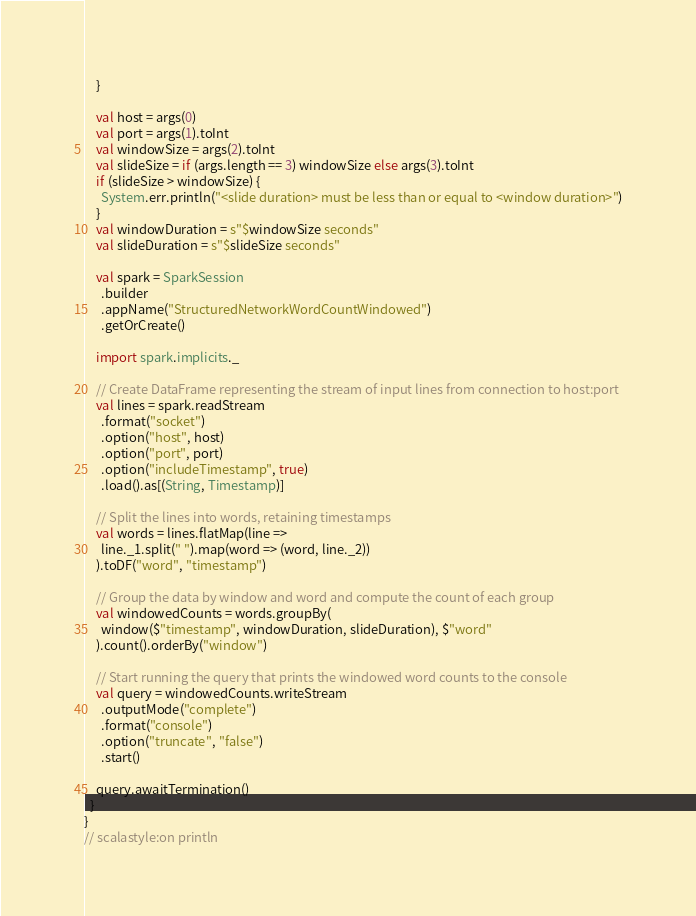Convert code to text. <code><loc_0><loc_0><loc_500><loc_500><_Scala_>    }

    val host = args(0)
    val port = args(1).toInt
    val windowSize = args(2).toInt
    val slideSize = if (args.length == 3) windowSize else args(3).toInt
    if (slideSize > windowSize) {
      System.err.println("<slide duration> must be less than or equal to <window duration>")
    }
    val windowDuration = s"$windowSize seconds"
    val slideDuration = s"$slideSize seconds"

    val spark = SparkSession
      .builder
      .appName("StructuredNetworkWordCountWindowed")
      .getOrCreate()

    import spark.implicits._

    // Create DataFrame representing the stream of input lines from connection to host:port
    val lines = spark.readStream
      .format("socket")
      .option("host", host)
      .option("port", port)
      .option("includeTimestamp", true)
      .load().as[(String, Timestamp)]

    // Split the lines into words, retaining timestamps
    val words = lines.flatMap(line =>
      line._1.split(" ").map(word => (word, line._2))
    ).toDF("word", "timestamp")

    // Group the data by window and word and compute the count of each group
    val windowedCounts = words.groupBy(
      window($"timestamp", windowDuration, slideDuration), $"word"
    ).count().orderBy("window")

    // Start running the query that prints the windowed word counts to the console
    val query = windowedCounts.writeStream
      .outputMode("complete")
      .format("console")
      .option("truncate", "false")
      .start()

    query.awaitTermination()
  }
}
// scalastyle:on println
</code> 